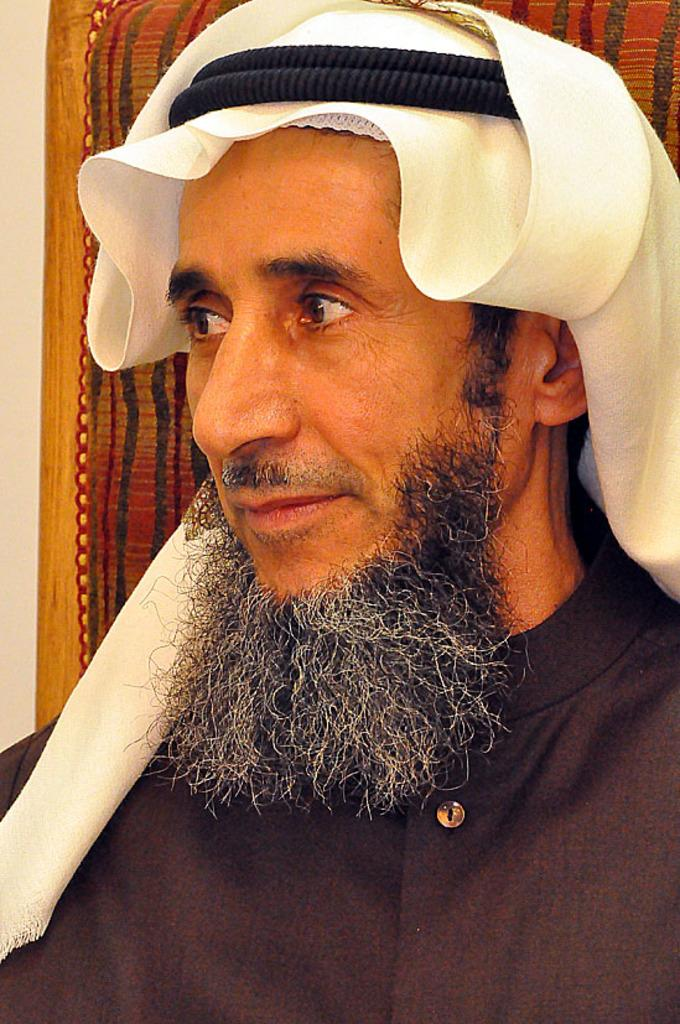Who or what is the main subject in the image? There is a person in the image. What type of headwear is the person wearing? The person is wearing an "Arab turban". What piece of furniture is visible behind the person? There is a chair visible behind the person. What is located behind the chair in the image? There is a wall behind the chair. What position does the tooth hold in the image? There is no tooth present in the image. How many rays are emanating from the person's head in the image? There are no rays emanating from the person's head in the image. 